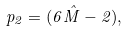Convert formula to latex. <formula><loc_0><loc_0><loc_500><loc_500>p _ { 2 } = ( 6 \hat { M } - 2 ) ,</formula> 